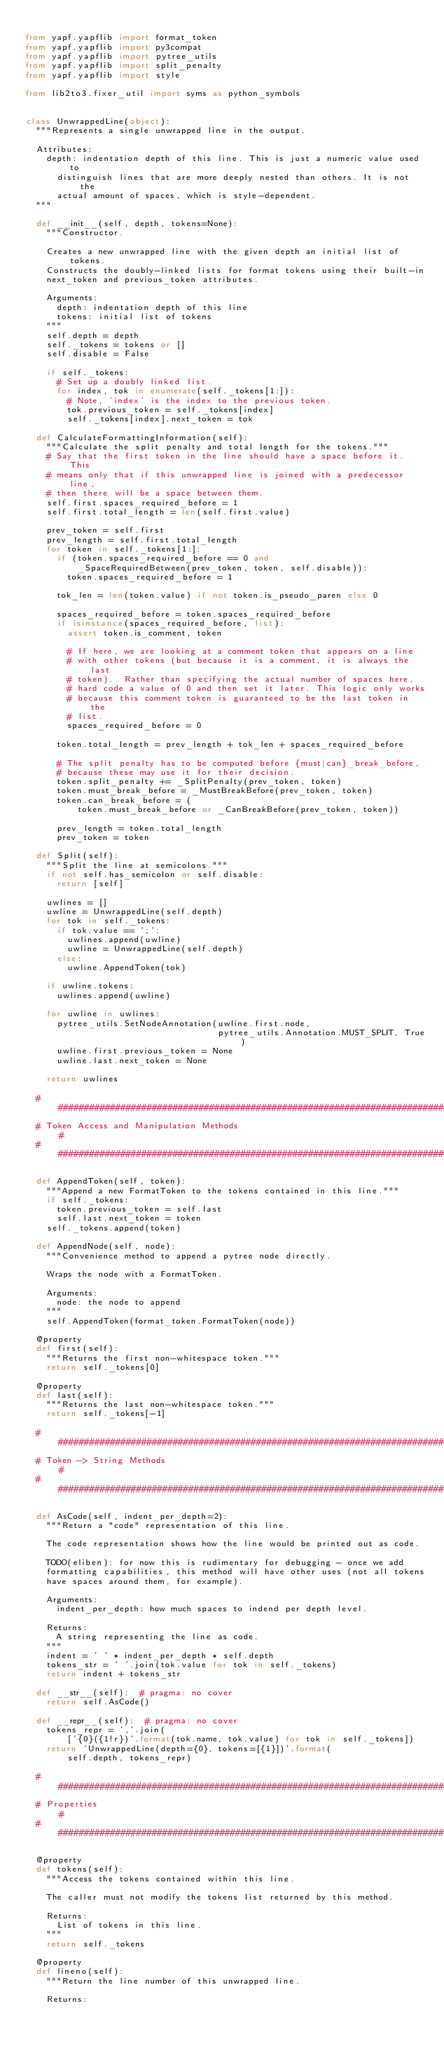<code> <loc_0><loc_0><loc_500><loc_500><_Python_>
from yapf.yapflib import format_token
from yapf.yapflib import py3compat
from yapf.yapflib import pytree_utils
from yapf.yapflib import split_penalty
from yapf.yapflib import style

from lib2to3.fixer_util import syms as python_symbols


class UnwrappedLine(object):
  """Represents a single unwrapped line in the output.

  Attributes:
    depth: indentation depth of this line. This is just a numeric value used to
      distinguish lines that are more deeply nested than others. It is not the
      actual amount of spaces, which is style-dependent.
  """

  def __init__(self, depth, tokens=None):
    """Constructor.

    Creates a new unwrapped line with the given depth an initial list of tokens.
    Constructs the doubly-linked lists for format tokens using their built-in
    next_token and previous_token attributes.

    Arguments:
      depth: indentation depth of this line
      tokens: initial list of tokens
    """
    self.depth = depth
    self._tokens = tokens or []
    self.disable = False

    if self._tokens:
      # Set up a doubly linked list.
      for index, tok in enumerate(self._tokens[1:]):
        # Note, 'index' is the index to the previous token.
        tok.previous_token = self._tokens[index]
        self._tokens[index].next_token = tok

  def CalculateFormattingInformation(self):
    """Calculate the split penalty and total length for the tokens."""
    # Say that the first token in the line should have a space before it. This
    # means only that if this unwrapped line is joined with a predecessor line,
    # then there will be a space between them.
    self.first.spaces_required_before = 1
    self.first.total_length = len(self.first.value)

    prev_token = self.first
    prev_length = self.first.total_length
    for token in self._tokens[1:]:
      if (token.spaces_required_before == 0 and
          _SpaceRequiredBetween(prev_token, token, self.disable)):
        token.spaces_required_before = 1

      tok_len = len(token.value) if not token.is_pseudo_paren else 0

      spaces_required_before = token.spaces_required_before
      if isinstance(spaces_required_before, list):
        assert token.is_comment, token

        # If here, we are looking at a comment token that appears on a line
        # with other tokens (but because it is a comment, it is always the last
        # token).  Rather than specifying the actual number of spaces here,
        # hard code a value of 0 and then set it later. This logic only works
        # because this comment token is guaranteed to be the last token in the
        # list.
        spaces_required_before = 0

      token.total_length = prev_length + tok_len + spaces_required_before

      # The split penalty has to be computed before {must|can}_break_before,
      # because these may use it for their decision.
      token.split_penalty += _SplitPenalty(prev_token, token)
      token.must_break_before = _MustBreakBefore(prev_token, token)
      token.can_break_before = (
          token.must_break_before or _CanBreakBefore(prev_token, token))

      prev_length = token.total_length
      prev_token = token

  def Split(self):
    """Split the line at semicolons."""
    if not self.has_semicolon or self.disable:
      return [self]

    uwlines = []
    uwline = UnwrappedLine(self.depth)
    for tok in self._tokens:
      if tok.value == ';':
        uwlines.append(uwline)
        uwline = UnwrappedLine(self.depth)
      else:
        uwline.AppendToken(tok)

    if uwline.tokens:
      uwlines.append(uwline)

    for uwline in uwlines:
      pytree_utils.SetNodeAnnotation(uwline.first.node,
                                     pytree_utils.Annotation.MUST_SPLIT, True)
      uwline.first.previous_token = None
      uwline.last.next_token = None

    return uwlines

  ############################################################################
  # Token Access and Manipulation Methods                                    #
  ############################################################################

  def AppendToken(self, token):
    """Append a new FormatToken to the tokens contained in this line."""
    if self._tokens:
      token.previous_token = self.last
      self.last.next_token = token
    self._tokens.append(token)

  def AppendNode(self, node):
    """Convenience method to append a pytree node directly.

    Wraps the node with a FormatToken.

    Arguments:
      node: the node to append
    """
    self.AppendToken(format_token.FormatToken(node))

  @property
  def first(self):
    """Returns the first non-whitespace token."""
    return self._tokens[0]

  @property
  def last(self):
    """Returns the last non-whitespace token."""
    return self._tokens[-1]

  ############################################################################
  # Token -> String Methods                                                  #
  ############################################################################

  def AsCode(self, indent_per_depth=2):
    """Return a "code" representation of this line.

    The code representation shows how the line would be printed out as code.

    TODO(eliben): for now this is rudimentary for debugging - once we add
    formatting capabilities, this method will have other uses (not all tokens
    have spaces around them, for example).

    Arguments:
      indent_per_depth: how much spaces to indend per depth level.

    Returns:
      A string representing the line as code.
    """
    indent = ' ' * indent_per_depth * self.depth
    tokens_str = ' '.join(tok.value for tok in self._tokens)
    return indent + tokens_str

  def __str__(self):  # pragma: no cover
    return self.AsCode()

  def __repr__(self):  # pragma: no cover
    tokens_repr = ','.join(
        ['{0}({1!r})'.format(tok.name, tok.value) for tok in self._tokens])
    return 'UnwrappedLine(depth={0}, tokens=[{1}])'.format(
        self.depth, tokens_repr)

  ############################################################################
  # Properties                                                               #
  ############################################################################

  @property
  def tokens(self):
    """Access the tokens contained within this line.

    The caller must not modify the tokens list returned by this method.

    Returns:
      List of tokens in this line.
    """
    return self._tokens

  @property
  def lineno(self):
    """Return the line number of this unwrapped line.

    Returns:</code> 